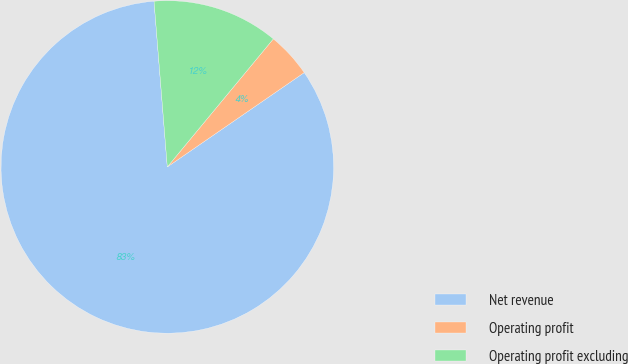Convert chart. <chart><loc_0><loc_0><loc_500><loc_500><pie_chart><fcel>Net revenue<fcel>Operating profit<fcel>Operating profit excluding<nl><fcel>83.33%<fcel>4.39%<fcel>12.28%<nl></chart> 